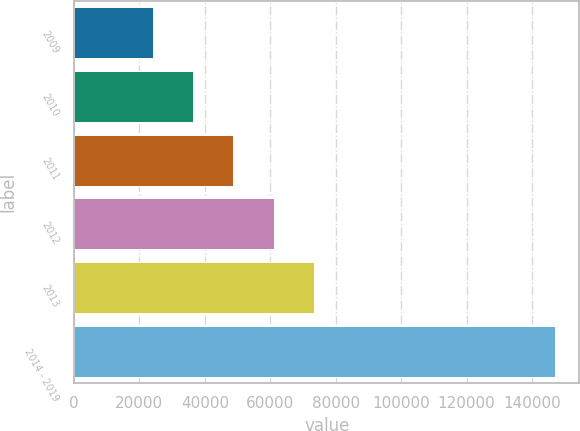Convert chart to OTSL. <chart><loc_0><loc_0><loc_500><loc_500><bar_chart><fcel>2009<fcel>2010<fcel>2011<fcel>2012<fcel>2013<fcel>2014 - 2019<nl><fcel>24138<fcel>36436.8<fcel>48735.6<fcel>61034.4<fcel>73333.2<fcel>147126<nl></chart> 